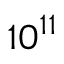Convert formula to latex. <formula><loc_0><loc_0><loc_500><loc_500>1 0 ^ { 1 1 }</formula> 